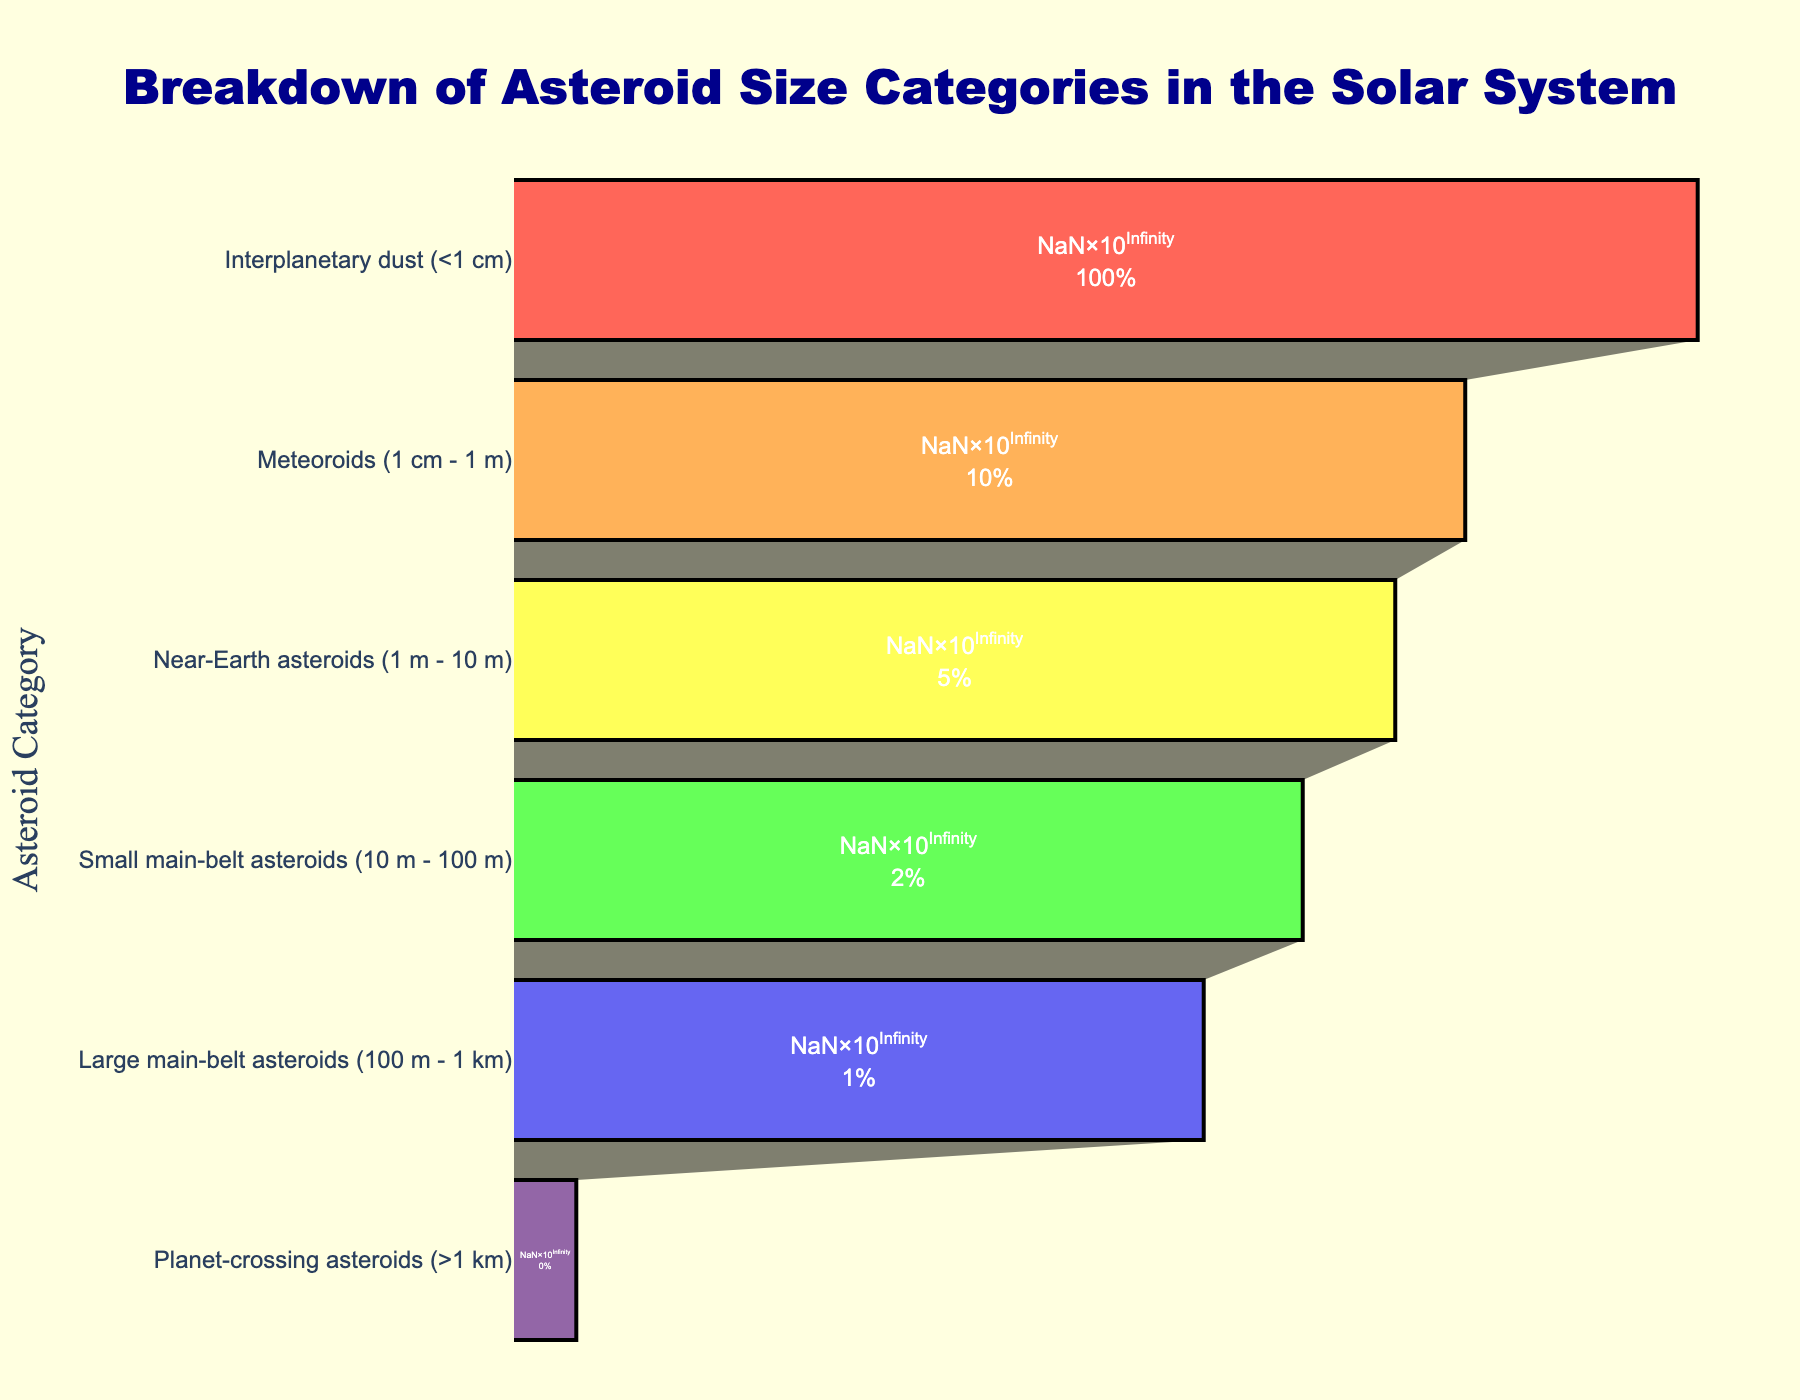What is the title of the funnel chart? The title is located at the top of the chart. It is in large, bold text and centered.
Answer: Breakdown of Asteroid Size Categories in the Solar System Which asteroid size category has the highest count? The category with the largest bar extends furthest on the x-axis.
Answer: Interplanetary dust (<1 cm) How many Planet-crossing asteroids (>1 km) are observed? The count for this category is labelled inside the bar for "Planet-crossing asteroids (>1 km)" and reads "1,500".
Answer: 1,500 Which two categories have the closest counts? Compare the lengths of the bars and their count labels. The two closest counts are "Large main-belt asteroids (100 m - 1 km)" and "Small main-belt asteroids (10 m - 100 m)", which are 750,000 and 2,000,000 respectively.
Answer: Large main-belt asteroids (100 m - 1 km) and Small main-belt asteroids (10 m - 100 m) What percentage of the total counts does the Meteoroids (1 cm - 1 m) category represent? Calculate the percentage by taking the count of Meteoroids (1 cm - 1 m), which is 10,000,000, and dividing it by the total count of all categories, then multiplying by 100. Total count = 116,505,000. Percentage = (10,000,000 / 116,505,000) * 100.
Answer: Approximately 8.6% How does the count of Near-Earth asteroids (1 m - 10 m) compare to the count of Large main-belt asteroids (100 m - 1 km)? Compare the counts directly from the chart: Near-Earth asteroids (5,000,000) and Large main-belt asteroids (750,000). 5,000,000 is higher than 750,000.
Answer: Near-Earth asteroids (1 m - 10 m) have more counts Is the distribution of asteroid sizes depicted in a linear or logarithmic scale on the x-axis? Read the axis labels; the x-axis is labeled "Count (Log Scale)".
Answer: Logarithmic scale What is the color used for representing Small main-belt asteroids (10 m - 100 m)? Observe the bar's color on the chart, which is the same as the label "Small main-belt asteroids (10 m - 100 m)". It appears as a yellow color.
Answer: Yellow Rank the asteroid categories from largest to smallest count. Refer to the lengths and labels of the bars, starting from the largest to smallest: Interplanetary dust (<1 cm), Meteoroids (1 cm - 1 m), Near-Earth asteroids (1 m - 10 m), Small main-belt asteroids (10 m - 100 m), Large main-belt asteroids (100 m - 1 km), Planet-crossing asteroids (>1 km).
Answer: Interplanetary dust, Meteoroids, Near-Earth asteroids, Small main-belt asteroids, Large main-belt asteroids, Planet-crossing asteroids 